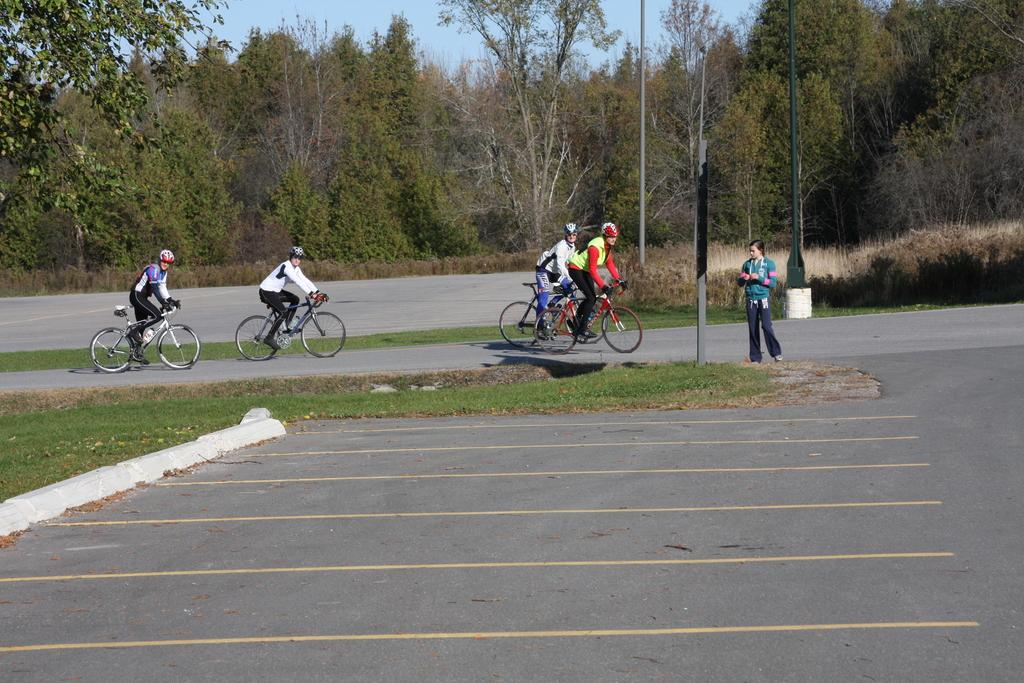What are the people in the image doing? The people in the image are riding bicycles. What safety precaution are the people taking while riding bicycles? The people are wearing helmets. Can you describe the woman's position in the image? There is a woman standing on the road. What type of objects can be seen in the image besides the people and the woman? There are poles and trees visible in the image. What is the color of the sky in the image? The sky is blue in the image. What type of house can be seen in the image? There is no house present in the image. What is the woman using to whip the bicycles in the image? The woman is not whipping the bicycles in the image; she is standing on the road. 